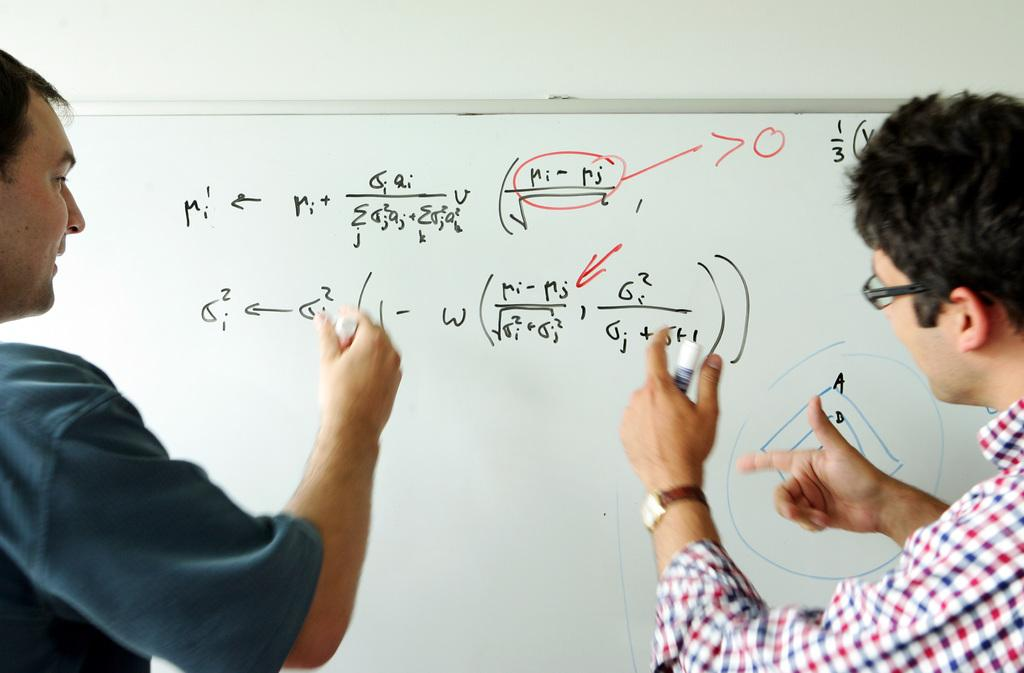Provide a one-sentence caption for the provided image. A whiteboard with math problems that include ri-rj. 